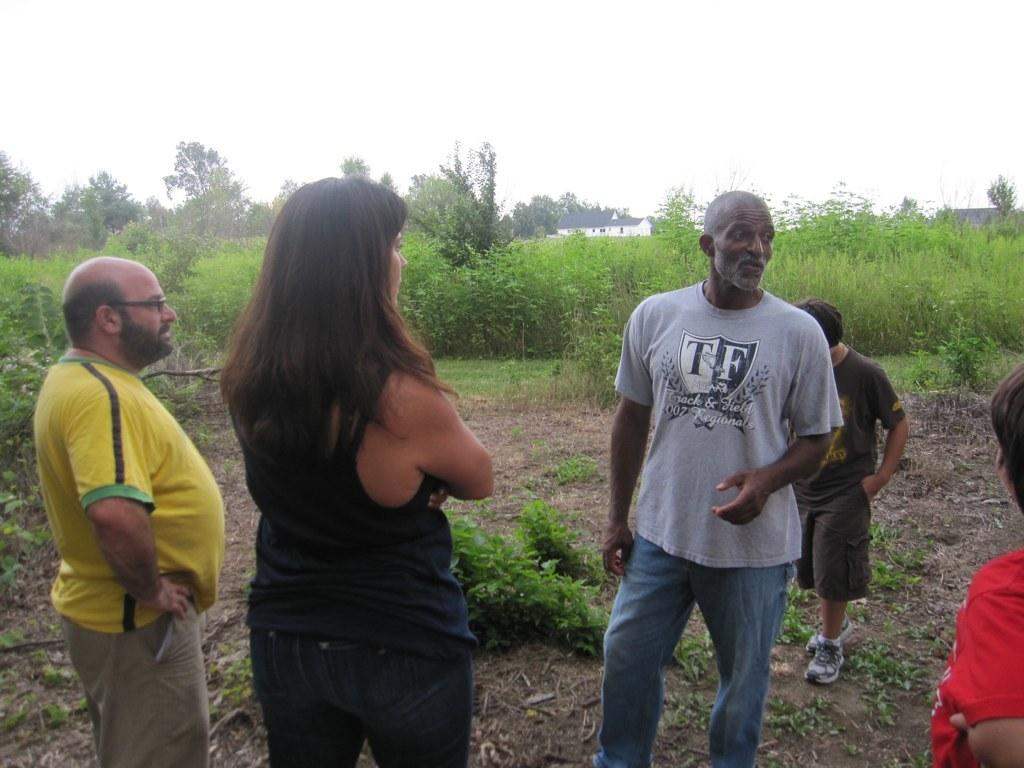What are the people in the image doing? The people in the image are standing on the ground. What can be seen in the background of the image? In the background of the image, there are plants, trees, and the sky. What type of game is being played in the wilderness in the image? There is no game being played in the image, nor is there any indication of wilderness. 